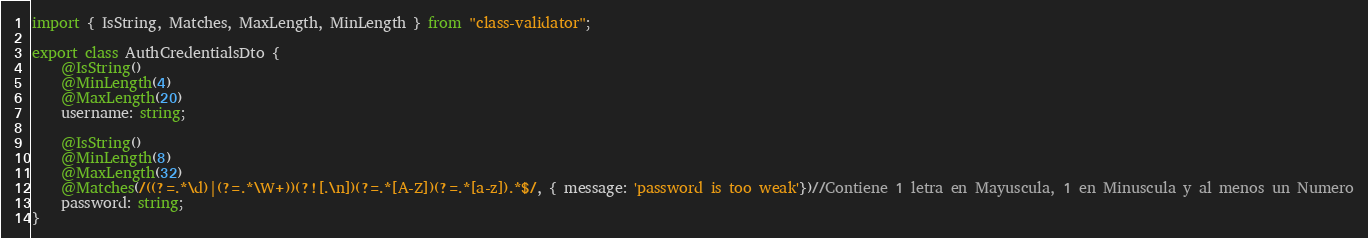<code> <loc_0><loc_0><loc_500><loc_500><_TypeScript_>import { IsString, Matches, MaxLength, MinLength } from "class-validator";

export class AuthCredentialsDto {
    @IsString()
    @MinLength(4)
    @MaxLength(20)
    username: string;

    @IsString()
    @MinLength(8)
    @MaxLength(32)
    @Matches(/((?=.*\d)|(?=.*\W+))(?![.\n])(?=.*[A-Z])(?=.*[a-z]).*$/, { message: 'password is too weak'})//Contiene 1 letra en Mayuscula, 1 en Minuscula y al menos un Numero
    password: string;
}</code> 